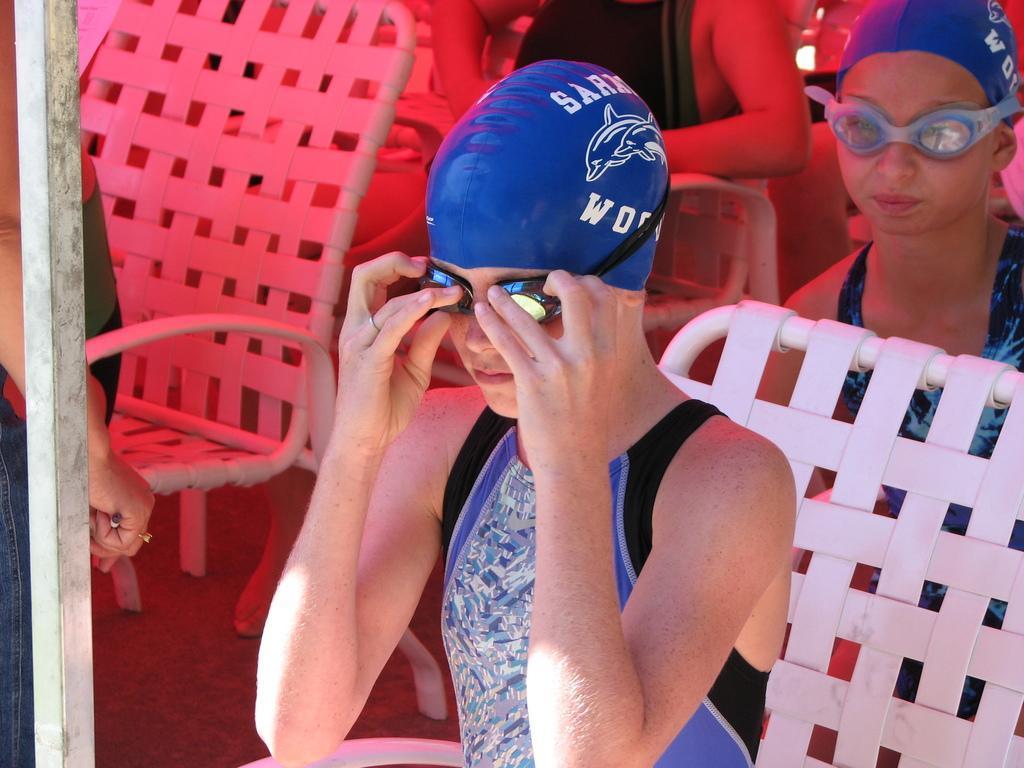Please provide a concise description of this image. In this picture we can see there are three persons sitting on chairs. On the left side of the image, there is a pole and a person is standing. 